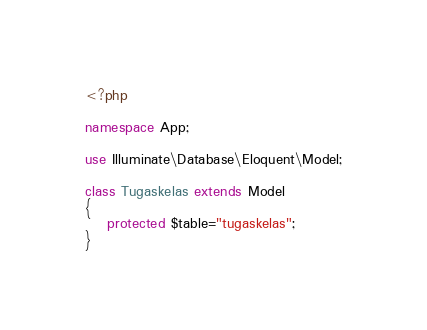<code> <loc_0><loc_0><loc_500><loc_500><_PHP_><?php

namespace App;

use Illuminate\Database\Eloquent\Model;

class Tugaskelas extends Model
{
    protected $table="tugaskelas";
}
</code> 